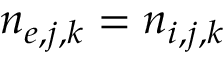Convert formula to latex. <formula><loc_0><loc_0><loc_500><loc_500>n _ { e , j , k } = n _ { i , j , k }</formula> 